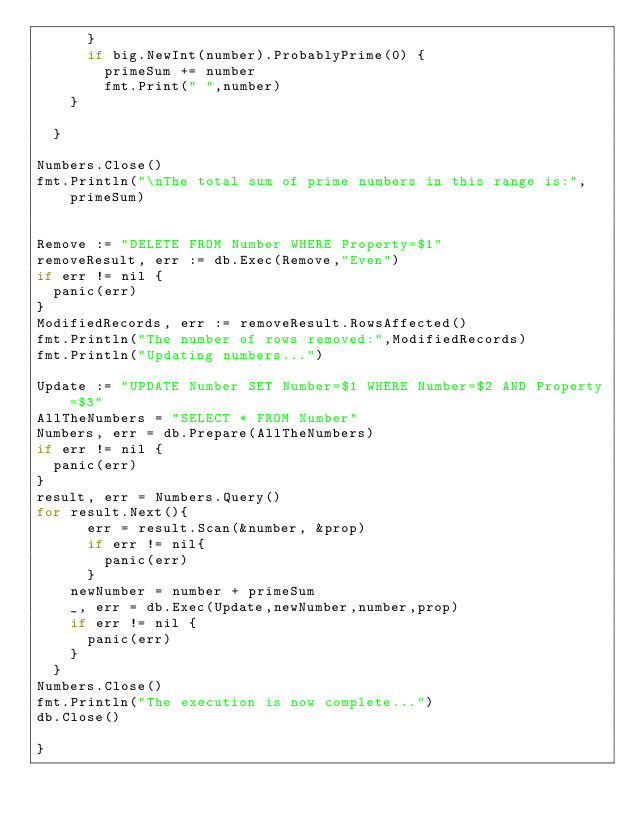<code> <loc_0><loc_0><loc_500><loc_500><_Go_>	    }
	    if big.NewInt(number).ProbablyPrime(0) {
		    primeSum += number
		    fmt.Print(" ",number)
		}
		
	}

Numbers.Close()
fmt.Println("\nThe total sum of prime numbers in this range is:",primeSum)


Remove := "DELETE FROM Number WHERE Property=$1"
removeResult, err := db.Exec(Remove,"Even")
if err != nil {
	panic(err)
}
ModifiedRecords, err := removeResult.RowsAffected()
fmt.Println("The number of rows removed:",ModifiedRecords)
fmt.Println("Updating numbers...")

Update := "UPDATE Number SET Number=$1 WHERE Number=$2 AND Property=$3"
AllTheNumbers = "SELECT * FROM Number"
Numbers, err = db.Prepare(AllTheNumbers)
if err != nil {
	panic(err)
} 
result, err = Numbers.Query()
for result.Next(){
	    err = result.Scan(&number, &prop)
	    if err != nil{
	    	panic(err)
	    }
		newNumber = number + primeSum
		_, err = db.Exec(Update,newNumber,number,prop)
		if err != nil {
			panic(err)
		} 
	}
Numbers.Close()
fmt.Println("The execution is now complete...")
db.Close()

}</code> 